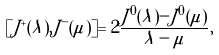Convert formula to latex. <formula><loc_0><loc_0><loc_500><loc_500>[ J ^ { + } ( \lambda ) , J ^ { - } ( \mu ) ] = 2 \frac { J ^ { 0 } ( \lambda ) - J ^ { 0 } ( \mu ) } { \lambda - \mu } ,</formula> 